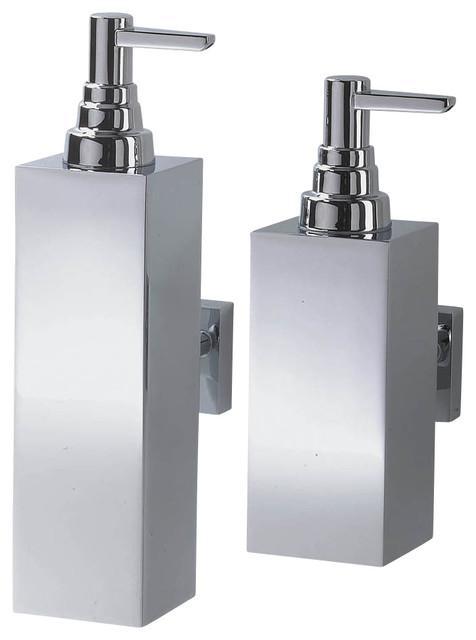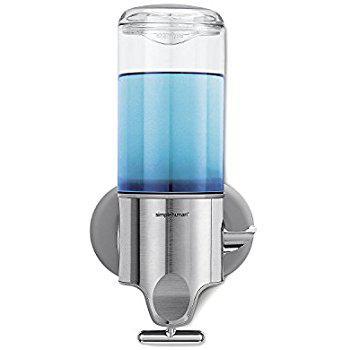The first image is the image on the left, the second image is the image on the right. For the images displayed, is the sentence "One image features an opaque dispenser style with a top nozzle, and the other features a style that dispenses from the bottom and has a clear body." factually correct? Answer yes or no. Yes. The first image is the image on the left, the second image is the image on the right. Analyze the images presented: Is the assertion "At least one soap dispenser has a pump on top." valid? Answer yes or no. Yes. 